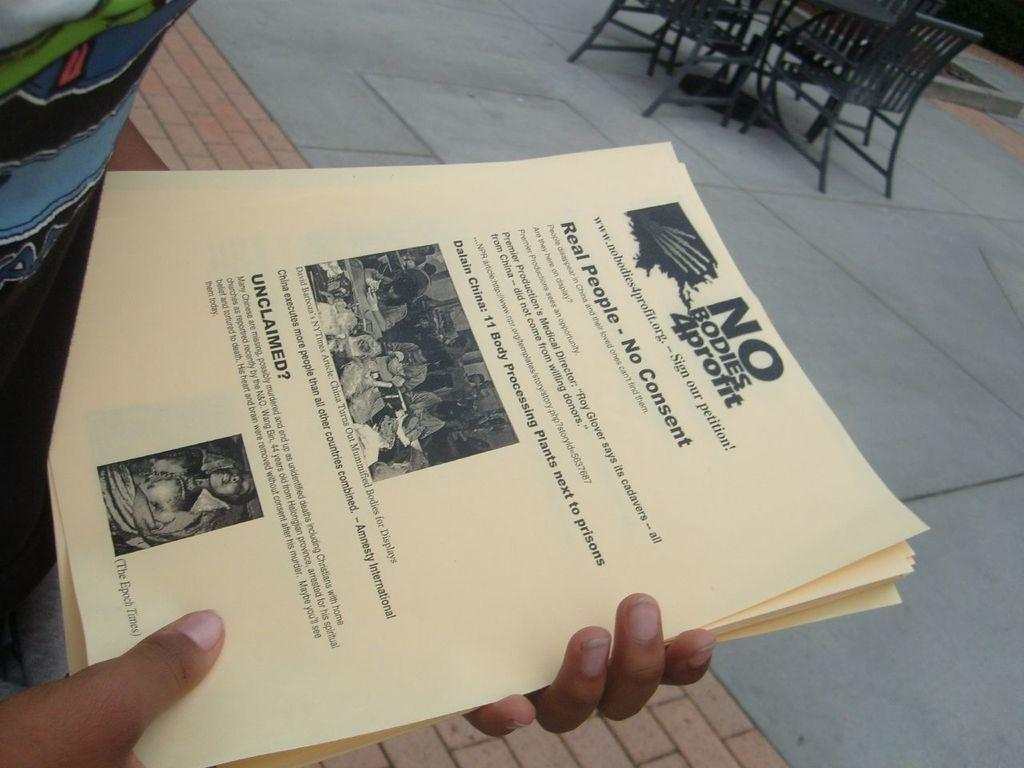<image>
Summarize the visual content of the image. Flyers for No Bodies 4 Profit mention 11 body processing plants next to prisons. 